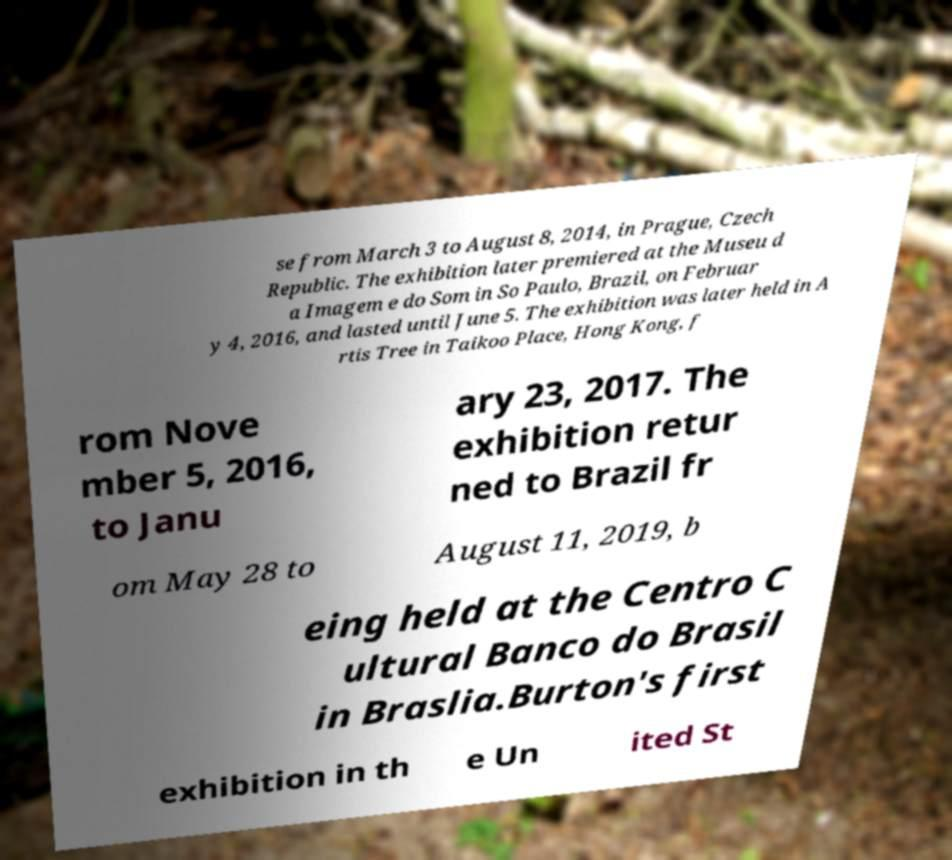What messages or text are displayed in this image? I need them in a readable, typed format. se from March 3 to August 8, 2014, in Prague, Czech Republic. The exhibition later premiered at the Museu d a Imagem e do Som in So Paulo, Brazil, on Februar y 4, 2016, and lasted until June 5. The exhibition was later held in A rtis Tree in Taikoo Place, Hong Kong, f rom Nove mber 5, 2016, to Janu ary 23, 2017. The exhibition retur ned to Brazil fr om May 28 to August 11, 2019, b eing held at the Centro C ultural Banco do Brasil in Braslia.Burton's first exhibition in th e Un ited St 